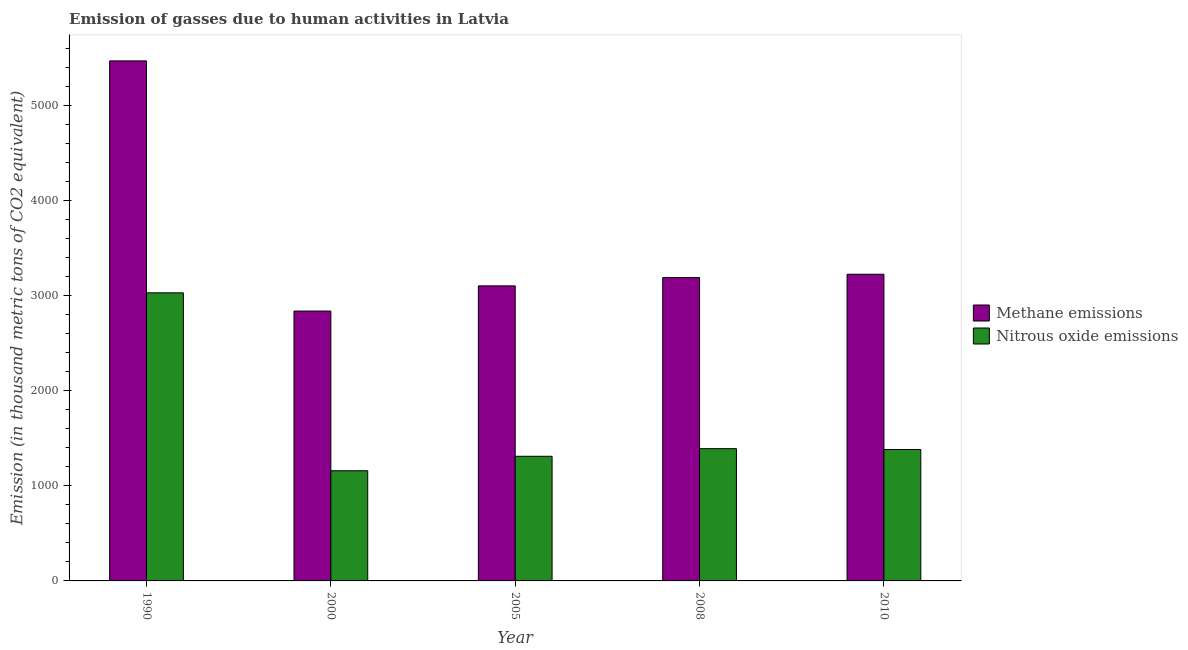How many different coloured bars are there?
Offer a terse response. 2. How many groups of bars are there?
Offer a very short reply. 5. How many bars are there on the 3rd tick from the right?
Your response must be concise. 2. What is the amount of nitrous oxide emissions in 2000?
Provide a short and direct response. 1159.4. Across all years, what is the maximum amount of nitrous oxide emissions?
Your response must be concise. 3031.8. Across all years, what is the minimum amount of methane emissions?
Ensure brevity in your answer.  2840. What is the total amount of nitrous oxide emissions in the graph?
Your answer should be compact. 8277.9. What is the difference between the amount of methane emissions in 2000 and that in 2005?
Offer a terse response. -265. What is the difference between the amount of methane emissions in 2008 and the amount of nitrous oxide emissions in 2010?
Provide a short and direct response. -35.3. What is the average amount of methane emissions per year?
Offer a terse response. 3567.46. In the year 2005, what is the difference between the amount of nitrous oxide emissions and amount of methane emissions?
Your answer should be compact. 0. What is the ratio of the amount of methane emissions in 2000 to that in 2010?
Keep it short and to the point. 0.88. Is the amount of methane emissions in 1990 less than that in 2008?
Provide a short and direct response. No. What is the difference between the highest and the second highest amount of nitrous oxide emissions?
Make the answer very short. 1639.9. What is the difference between the highest and the lowest amount of methane emissions?
Offer a terse response. 2632.8. What does the 2nd bar from the left in 2008 represents?
Make the answer very short. Nitrous oxide emissions. What does the 2nd bar from the right in 2008 represents?
Your response must be concise. Methane emissions. How many bars are there?
Give a very brief answer. 10. How many years are there in the graph?
Make the answer very short. 5. Does the graph contain any zero values?
Ensure brevity in your answer.  No. Does the graph contain grids?
Keep it short and to the point. No. How are the legend labels stacked?
Offer a very short reply. Vertical. What is the title of the graph?
Keep it short and to the point. Emission of gasses due to human activities in Latvia. What is the label or title of the X-axis?
Your answer should be compact. Year. What is the label or title of the Y-axis?
Ensure brevity in your answer.  Emission (in thousand metric tons of CO2 equivalent). What is the Emission (in thousand metric tons of CO2 equivalent) in Methane emissions in 1990?
Make the answer very short. 5472.8. What is the Emission (in thousand metric tons of CO2 equivalent) of Nitrous oxide emissions in 1990?
Make the answer very short. 3031.8. What is the Emission (in thousand metric tons of CO2 equivalent) in Methane emissions in 2000?
Provide a short and direct response. 2840. What is the Emission (in thousand metric tons of CO2 equivalent) of Nitrous oxide emissions in 2000?
Provide a short and direct response. 1159.4. What is the Emission (in thousand metric tons of CO2 equivalent) of Methane emissions in 2005?
Offer a very short reply. 3105. What is the Emission (in thousand metric tons of CO2 equivalent) in Nitrous oxide emissions in 2005?
Ensure brevity in your answer.  1311.8. What is the Emission (in thousand metric tons of CO2 equivalent) of Methane emissions in 2008?
Make the answer very short. 3192.1. What is the Emission (in thousand metric tons of CO2 equivalent) in Nitrous oxide emissions in 2008?
Offer a very short reply. 1391.9. What is the Emission (in thousand metric tons of CO2 equivalent) in Methane emissions in 2010?
Give a very brief answer. 3227.4. What is the Emission (in thousand metric tons of CO2 equivalent) in Nitrous oxide emissions in 2010?
Your answer should be very brief. 1383. Across all years, what is the maximum Emission (in thousand metric tons of CO2 equivalent) of Methane emissions?
Your answer should be compact. 5472.8. Across all years, what is the maximum Emission (in thousand metric tons of CO2 equivalent) of Nitrous oxide emissions?
Your answer should be compact. 3031.8. Across all years, what is the minimum Emission (in thousand metric tons of CO2 equivalent) of Methane emissions?
Your response must be concise. 2840. Across all years, what is the minimum Emission (in thousand metric tons of CO2 equivalent) of Nitrous oxide emissions?
Give a very brief answer. 1159.4. What is the total Emission (in thousand metric tons of CO2 equivalent) of Methane emissions in the graph?
Offer a very short reply. 1.78e+04. What is the total Emission (in thousand metric tons of CO2 equivalent) of Nitrous oxide emissions in the graph?
Provide a succinct answer. 8277.9. What is the difference between the Emission (in thousand metric tons of CO2 equivalent) in Methane emissions in 1990 and that in 2000?
Provide a short and direct response. 2632.8. What is the difference between the Emission (in thousand metric tons of CO2 equivalent) in Nitrous oxide emissions in 1990 and that in 2000?
Provide a short and direct response. 1872.4. What is the difference between the Emission (in thousand metric tons of CO2 equivalent) in Methane emissions in 1990 and that in 2005?
Make the answer very short. 2367.8. What is the difference between the Emission (in thousand metric tons of CO2 equivalent) of Nitrous oxide emissions in 1990 and that in 2005?
Give a very brief answer. 1720. What is the difference between the Emission (in thousand metric tons of CO2 equivalent) of Methane emissions in 1990 and that in 2008?
Offer a very short reply. 2280.7. What is the difference between the Emission (in thousand metric tons of CO2 equivalent) of Nitrous oxide emissions in 1990 and that in 2008?
Your answer should be very brief. 1639.9. What is the difference between the Emission (in thousand metric tons of CO2 equivalent) of Methane emissions in 1990 and that in 2010?
Your response must be concise. 2245.4. What is the difference between the Emission (in thousand metric tons of CO2 equivalent) of Nitrous oxide emissions in 1990 and that in 2010?
Offer a terse response. 1648.8. What is the difference between the Emission (in thousand metric tons of CO2 equivalent) in Methane emissions in 2000 and that in 2005?
Make the answer very short. -265. What is the difference between the Emission (in thousand metric tons of CO2 equivalent) in Nitrous oxide emissions in 2000 and that in 2005?
Your response must be concise. -152.4. What is the difference between the Emission (in thousand metric tons of CO2 equivalent) of Methane emissions in 2000 and that in 2008?
Keep it short and to the point. -352.1. What is the difference between the Emission (in thousand metric tons of CO2 equivalent) in Nitrous oxide emissions in 2000 and that in 2008?
Your response must be concise. -232.5. What is the difference between the Emission (in thousand metric tons of CO2 equivalent) in Methane emissions in 2000 and that in 2010?
Offer a terse response. -387.4. What is the difference between the Emission (in thousand metric tons of CO2 equivalent) of Nitrous oxide emissions in 2000 and that in 2010?
Provide a short and direct response. -223.6. What is the difference between the Emission (in thousand metric tons of CO2 equivalent) of Methane emissions in 2005 and that in 2008?
Offer a terse response. -87.1. What is the difference between the Emission (in thousand metric tons of CO2 equivalent) in Nitrous oxide emissions in 2005 and that in 2008?
Your answer should be very brief. -80.1. What is the difference between the Emission (in thousand metric tons of CO2 equivalent) in Methane emissions in 2005 and that in 2010?
Keep it short and to the point. -122.4. What is the difference between the Emission (in thousand metric tons of CO2 equivalent) of Nitrous oxide emissions in 2005 and that in 2010?
Your response must be concise. -71.2. What is the difference between the Emission (in thousand metric tons of CO2 equivalent) in Methane emissions in 2008 and that in 2010?
Ensure brevity in your answer.  -35.3. What is the difference between the Emission (in thousand metric tons of CO2 equivalent) of Methane emissions in 1990 and the Emission (in thousand metric tons of CO2 equivalent) of Nitrous oxide emissions in 2000?
Offer a terse response. 4313.4. What is the difference between the Emission (in thousand metric tons of CO2 equivalent) of Methane emissions in 1990 and the Emission (in thousand metric tons of CO2 equivalent) of Nitrous oxide emissions in 2005?
Give a very brief answer. 4161. What is the difference between the Emission (in thousand metric tons of CO2 equivalent) in Methane emissions in 1990 and the Emission (in thousand metric tons of CO2 equivalent) in Nitrous oxide emissions in 2008?
Ensure brevity in your answer.  4080.9. What is the difference between the Emission (in thousand metric tons of CO2 equivalent) in Methane emissions in 1990 and the Emission (in thousand metric tons of CO2 equivalent) in Nitrous oxide emissions in 2010?
Offer a terse response. 4089.8. What is the difference between the Emission (in thousand metric tons of CO2 equivalent) of Methane emissions in 2000 and the Emission (in thousand metric tons of CO2 equivalent) of Nitrous oxide emissions in 2005?
Provide a short and direct response. 1528.2. What is the difference between the Emission (in thousand metric tons of CO2 equivalent) of Methane emissions in 2000 and the Emission (in thousand metric tons of CO2 equivalent) of Nitrous oxide emissions in 2008?
Provide a short and direct response. 1448.1. What is the difference between the Emission (in thousand metric tons of CO2 equivalent) in Methane emissions in 2000 and the Emission (in thousand metric tons of CO2 equivalent) in Nitrous oxide emissions in 2010?
Your answer should be compact. 1457. What is the difference between the Emission (in thousand metric tons of CO2 equivalent) in Methane emissions in 2005 and the Emission (in thousand metric tons of CO2 equivalent) in Nitrous oxide emissions in 2008?
Give a very brief answer. 1713.1. What is the difference between the Emission (in thousand metric tons of CO2 equivalent) in Methane emissions in 2005 and the Emission (in thousand metric tons of CO2 equivalent) in Nitrous oxide emissions in 2010?
Your answer should be very brief. 1722. What is the difference between the Emission (in thousand metric tons of CO2 equivalent) of Methane emissions in 2008 and the Emission (in thousand metric tons of CO2 equivalent) of Nitrous oxide emissions in 2010?
Your answer should be compact. 1809.1. What is the average Emission (in thousand metric tons of CO2 equivalent) of Methane emissions per year?
Your answer should be very brief. 3567.46. What is the average Emission (in thousand metric tons of CO2 equivalent) of Nitrous oxide emissions per year?
Offer a very short reply. 1655.58. In the year 1990, what is the difference between the Emission (in thousand metric tons of CO2 equivalent) of Methane emissions and Emission (in thousand metric tons of CO2 equivalent) of Nitrous oxide emissions?
Provide a succinct answer. 2441. In the year 2000, what is the difference between the Emission (in thousand metric tons of CO2 equivalent) in Methane emissions and Emission (in thousand metric tons of CO2 equivalent) in Nitrous oxide emissions?
Offer a very short reply. 1680.6. In the year 2005, what is the difference between the Emission (in thousand metric tons of CO2 equivalent) of Methane emissions and Emission (in thousand metric tons of CO2 equivalent) of Nitrous oxide emissions?
Your answer should be very brief. 1793.2. In the year 2008, what is the difference between the Emission (in thousand metric tons of CO2 equivalent) of Methane emissions and Emission (in thousand metric tons of CO2 equivalent) of Nitrous oxide emissions?
Make the answer very short. 1800.2. In the year 2010, what is the difference between the Emission (in thousand metric tons of CO2 equivalent) in Methane emissions and Emission (in thousand metric tons of CO2 equivalent) in Nitrous oxide emissions?
Provide a short and direct response. 1844.4. What is the ratio of the Emission (in thousand metric tons of CO2 equivalent) in Methane emissions in 1990 to that in 2000?
Make the answer very short. 1.93. What is the ratio of the Emission (in thousand metric tons of CO2 equivalent) of Nitrous oxide emissions in 1990 to that in 2000?
Make the answer very short. 2.62. What is the ratio of the Emission (in thousand metric tons of CO2 equivalent) in Methane emissions in 1990 to that in 2005?
Give a very brief answer. 1.76. What is the ratio of the Emission (in thousand metric tons of CO2 equivalent) of Nitrous oxide emissions in 1990 to that in 2005?
Make the answer very short. 2.31. What is the ratio of the Emission (in thousand metric tons of CO2 equivalent) of Methane emissions in 1990 to that in 2008?
Make the answer very short. 1.71. What is the ratio of the Emission (in thousand metric tons of CO2 equivalent) in Nitrous oxide emissions in 1990 to that in 2008?
Your answer should be very brief. 2.18. What is the ratio of the Emission (in thousand metric tons of CO2 equivalent) of Methane emissions in 1990 to that in 2010?
Give a very brief answer. 1.7. What is the ratio of the Emission (in thousand metric tons of CO2 equivalent) in Nitrous oxide emissions in 1990 to that in 2010?
Ensure brevity in your answer.  2.19. What is the ratio of the Emission (in thousand metric tons of CO2 equivalent) in Methane emissions in 2000 to that in 2005?
Give a very brief answer. 0.91. What is the ratio of the Emission (in thousand metric tons of CO2 equivalent) in Nitrous oxide emissions in 2000 to that in 2005?
Make the answer very short. 0.88. What is the ratio of the Emission (in thousand metric tons of CO2 equivalent) of Methane emissions in 2000 to that in 2008?
Your answer should be compact. 0.89. What is the ratio of the Emission (in thousand metric tons of CO2 equivalent) of Nitrous oxide emissions in 2000 to that in 2008?
Your response must be concise. 0.83. What is the ratio of the Emission (in thousand metric tons of CO2 equivalent) in Methane emissions in 2000 to that in 2010?
Provide a succinct answer. 0.88. What is the ratio of the Emission (in thousand metric tons of CO2 equivalent) in Nitrous oxide emissions in 2000 to that in 2010?
Give a very brief answer. 0.84. What is the ratio of the Emission (in thousand metric tons of CO2 equivalent) in Methane emissions in 2005 to that in 2008?
Keep it short and to the point. 0.97. What is the ratio of the Emission (in thousand metric tons of CO2 equivalent) of Nitrous oxide emissions in 2005 to that in 2008?
Provide a short and direct response. 0.94. What is the ratio of the Emission (in thousand metric tons of CO2 equivalent) of Methane emissions in 2005 to that in 2010?
Give a very brief answer. 0.96. What is the ratio of the Emission (in thousand metric tons of CO2 equivalent) in Nitrous oxide emissions in 2005 to that in 2010?
Ensure brevity in your answer.  0.95. What is the ratio of the Emission (in thousand metric tons of CO2 equivalent) of Nitrous oxide emissions in 2008 to that in 2010?
Keep it short and to the point. 1.01. What is the difference between the highest and the second highest Emission (in thousand metric tons of CO2 equivalent) of Methane emissions?
Your response must be concise. 2245.4. What is the difference between the highest and the second highest Emission (in thousand metric tons of CO2 equivalent) of Nitrous oxide emissions?
Offer a terse response. 1639.9. What is the difference between the highest and the lowest Emission (in thousand metric tons of CO2 equivalent) in Methane emissions?
Your answer should be compact. 2632.8. What is the difference between the highest and the lowest Emission (in thousand metric tons of CO2 equivalent) in Nitrous oxide emissions?
Make the answer very short. 1872.4. 